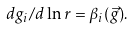Convert formula to latex. <formula><loc_0><loc_0><loc_500><loc_500>d g _ { i } / d \ln r = \beta _ { i } ( \vec { g } ) .</formula> 